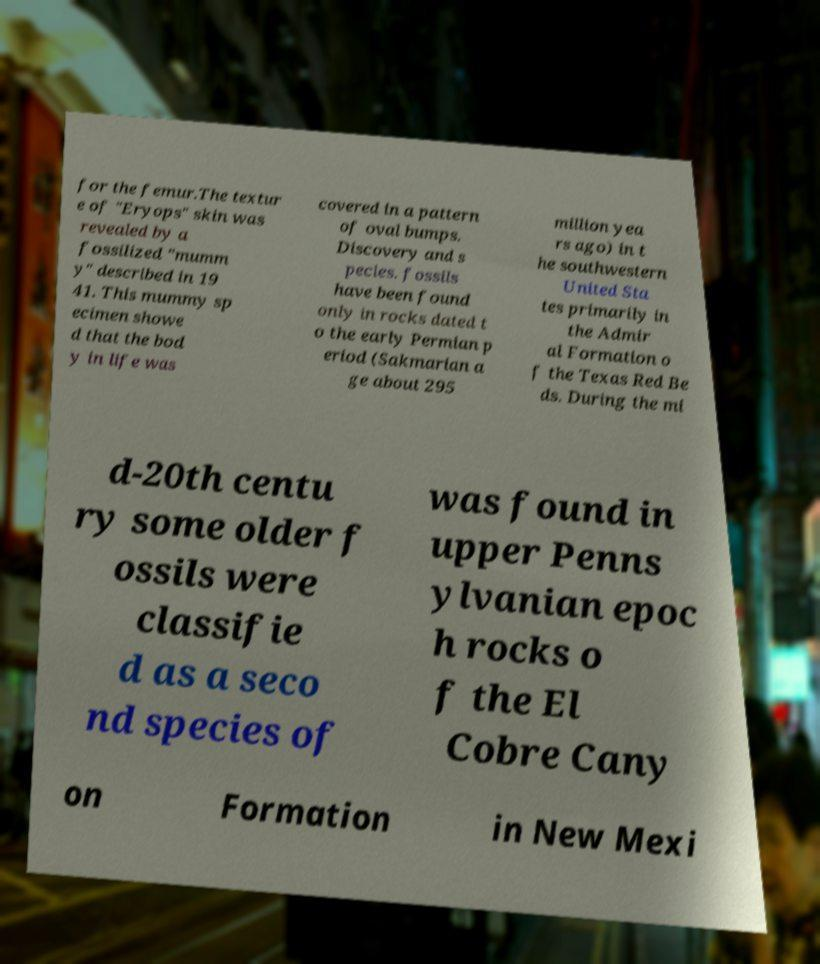What messages or text are displayed in this image? I need them in a readable, typed format. for the femur.The textur e of "Eryops" skin was revealed by a fossilized "mumm y" described in 19 41. This mummy sp ecimen showe d that the bod y in life was covered in a pattern of oval bumps. Discovery and s pecies. fossils have been found only in rocks dated t o the early Permian p eriod (Sakmarian a ge about 295 million yea rs ago) in t he southwestern United Sta tes primarily in the Admir al Formation o f the Texas Red Be ds. During the mi d-20th centu ry some older f ossils were classifie d as a seco nd species of was found in upper Penns ylvanian epoc h rocks o f the El Cobre Cany on Formation in New Mexi 